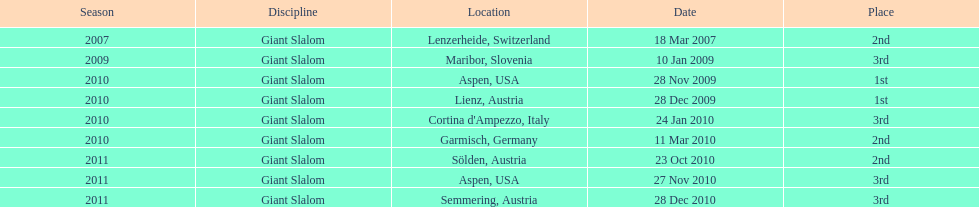Can you parse all the data within this table? {'header': ['Season', 'Discipline', 'Location', 'Date', 'Place'], 'rows': [['2007', 'Giant Slalom', 'Lenzerheide, Switzerland', '18 Mar 2007', '2nd'], ['2009', 'Giant Slalom', 'Maribor, Slovenia', '10 Jan 2009', '3rd'], ['2010', 'Giant Slalom', 'Aspen, USA', '28 Nov 2009', '1st'], ['2010', 'Giant Slalom', 'Lienz, Austria', '28 Dec 2009', '1st'], ['2010', 'Giant Slalom', "Cortina d'Ampezzo, Italy", '24 Jan 2010', '3rd'], ['2010', 'Giant Slalom', 'Garmisch, Germany', '11 Mar 2010', '2nd'], ['2011', 'Giant Slalom', 'Sölden, Austria', '23 Oct 2010', '2nd'], ['2011', 'Giant Slalom', 'Aspen, USA', '27 Nov 2010', '3rd'], ['2011', 'Giant Slalom', 'Semmering, Austria', '28 Dec 2010', '3rd']]} What is the total number of her 2nd place finishes on the list? 3. 